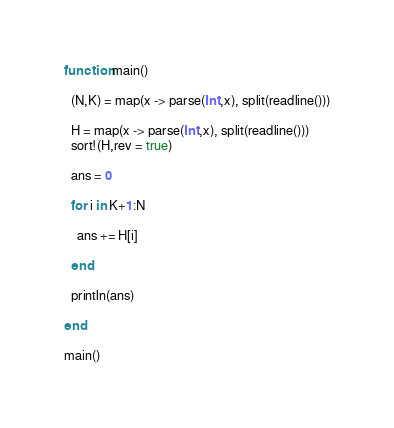<code> <loc_0><loc_0><loc_500><loc_500><_Julia_>function main()
  
  (N,K) = map(x -> parse(Int,x), split(readline()))
  
  H = map(x -> parse(Int,x), split(readline()))
  sort!(H,rev = true)
  
  ans = 0

  for i in K+1:N
    
    ans += H[i]
    
  end
  
  println(ans)
  
end

main()</code> 